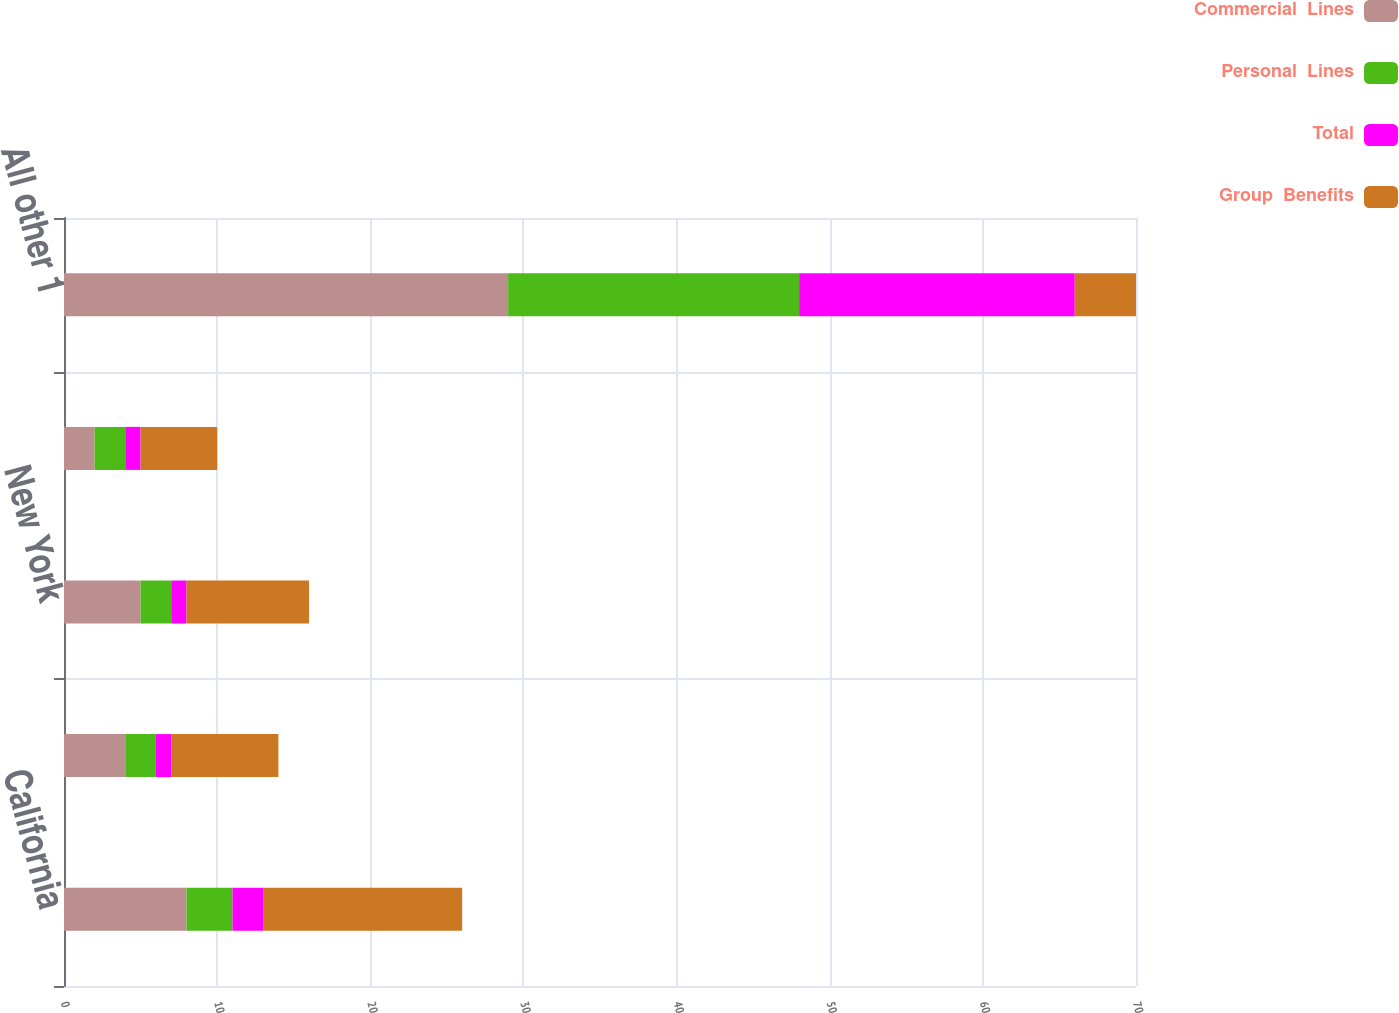Convert chart to OTSL. <chart><loc_0><loc_0><loc_500><loc_500><stacked_bar_chart><ecel><fcel>California<fcel>Texas<fcel>New York<fcel>Florida<fcel>All other 1<nl><fcel>Commercial  Lines<fcel>8<fcel>4<fcel>5<fcel>2<fcel>29<nl><fcel>Personal  Lines<fcel>3<fcel>2<fcel>2<fcel>2<fcel>19<nl><fcel>Total<fcel>2<fcel>1<fcel>1<fcel>1<fcel>18<nl><fcel>Group  Benefits<fcel>13<fcel>7<fcel>8<fcel>5<fcel>4<nl></chart> 